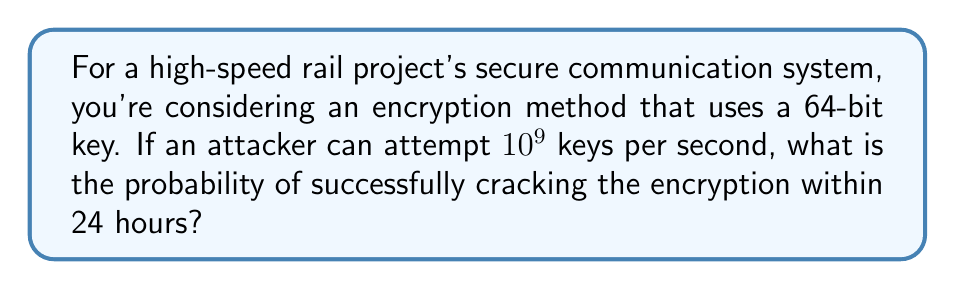Can you solve this math problem? Let's approach this step-by-step:

1) First, calculate the total number of possible keys:
   $$ \text{Total keys} = 2^{64} $$

2) Calculate how many keys can be attempted in 24 hours:
   $$ \text{Keys per second} = 10^9 $$
   $$ \text{Seconds in 24 hours} = 24 \times 60 \times 60 = 86,400 $$
   $$ \text{Keys attempted} = 10^9 \times 86,400 = 8.64 \times 10^{13} $$

3) The probability of success is the ratio of keys attempted to total keys:
   $$ P(\text{success}) = \frac{\text{Keys attempted}}{\text{Total keys}} $$
   $$ P(\text{success}) = \frac{8.64 \times 10^{13}}{2^{64}} $$

4) Simplify:
   $$ P(\text{success}) = \frac{8.64 \times 10^{13}}{1.8446744 \times 10^{19}} $$
   $$ P(\text{success}) \approx 4.68 \times 10^{-6} $$

5) Convert to percentage:
   $$ P(\text{success}) \approx 4.68 \times 10^{-4}\% $$
Answer: $4.68 \times 10^{-4}\%$ 